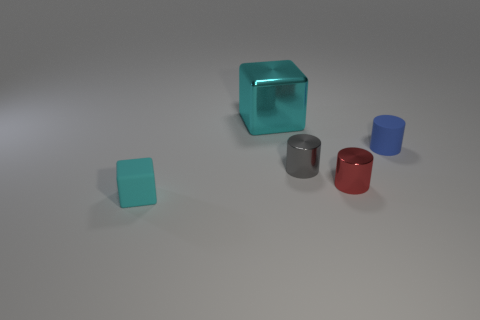How many cubes are tiny blue matte objects or red metallic objects?
Keep it short and to the point. 0. Does the blue thing have the same material as the big thing?
Your answer should be very brief. No. What number of other objects are there of the same color as the tiny rubber cylinder?
Offer a very short reply. 0. What is the shape of the matte thing on the right side of the large cyan shiny thing?
Make the answer very short. Cylinder. What number of objects are either green metallic blocks or large blocks?
Offer a terse response. 1. Does the matte cube have the same size as the red thing right of the cyan metallic cube?
Keep it short and to the point. Yes. How many other things are made of the same material as the small blue cylinder?
Provide a succinct answer. 1. What number of objects are blocks that are on the right side of the tiny matte block or rubber objects behind the small gray cylinder?
Offer a terse response. 2. What material is the small red thing that is the same shape as the tiny gray thing?
Your answer should be very brief. Metal. Is there a big cyan cylinder?
Your response must be concise. No. 